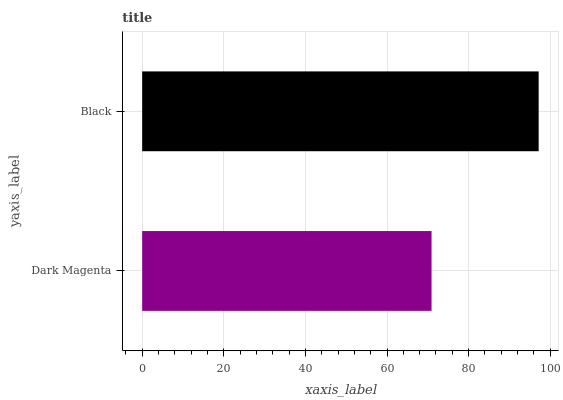Is Dark Magenta the minimum?
Answer yes or no. Yes. Is Black the maximum?
Answer yes or no. Yes. Is Black the minimum?
Answer yes or no. No. Is Black greater than Dark Magenta?
Answer yes or no. Yes. Is Dark Magenta less than Black?
Answer yes or no. Yes. Is Dark Magenta greater than Black?
Answer yes or no. No. Is Black less than Dark Magenta?
Answer yes or no. No. Is Black the high median?
Answer yes or no. Yes. Is Dark Magenta the low median?
Answer yes or no. Yes. Is Dark Magenta the high median?
Answer yes or no. No. Is Black the low median?
Answer yes or no. No. 